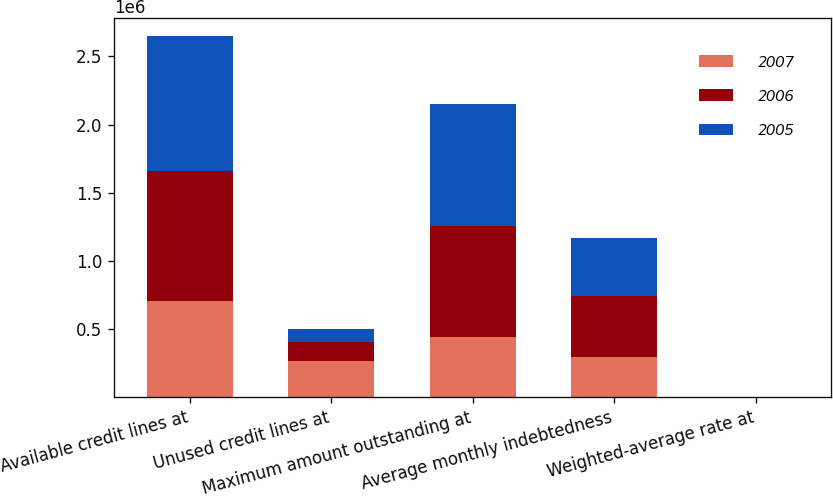Convert chart. <chart><loc_0><loc_0><loc_500><loc_500><stacked_bar_chart><ecel><fcel>Available credit lines at<fcel>Unused credit lines at<fcel>Maximum amount outstanding at<fcel>Average monthly indebtedness<fcel>Weighted-average rate at<nl><fcel>2007<fcel>705000<fcel>264000<fcel>441000<fcel>291000<fcel>5.47<nl><fcel>2006<fcel>955000<fcel>140000<fcel>815000<fcel>452000<fcel>5.81<nl><fcel>2005<fcel>990000<fcel>97000<fcel>893000<fcel>423000<fcel>4.89<nl></chart> 